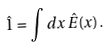Convert formula to latex. <formula><loc_0><loc_0><loc_500><loc_500>\hat { 1 } = \int d x \, \hat { E } ( x ) \, .</formula> 